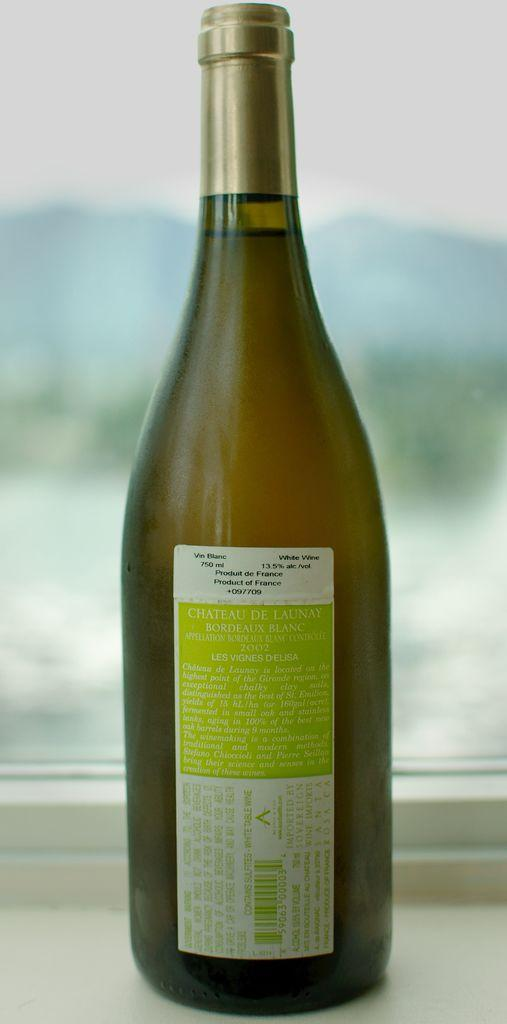<image>
Write a terse but informative summary of the picture. A bottle of wine that states Vin Blanc sits on a table. 